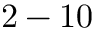Convert formula to latex. <formula><loc_0><loc_0><loc_500><loc_500>2 - 1 0</formula> 